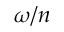Convert formula to latex. <formula><loc_0><loc_0><loc_500><loc_500>\omega / n</formula> 